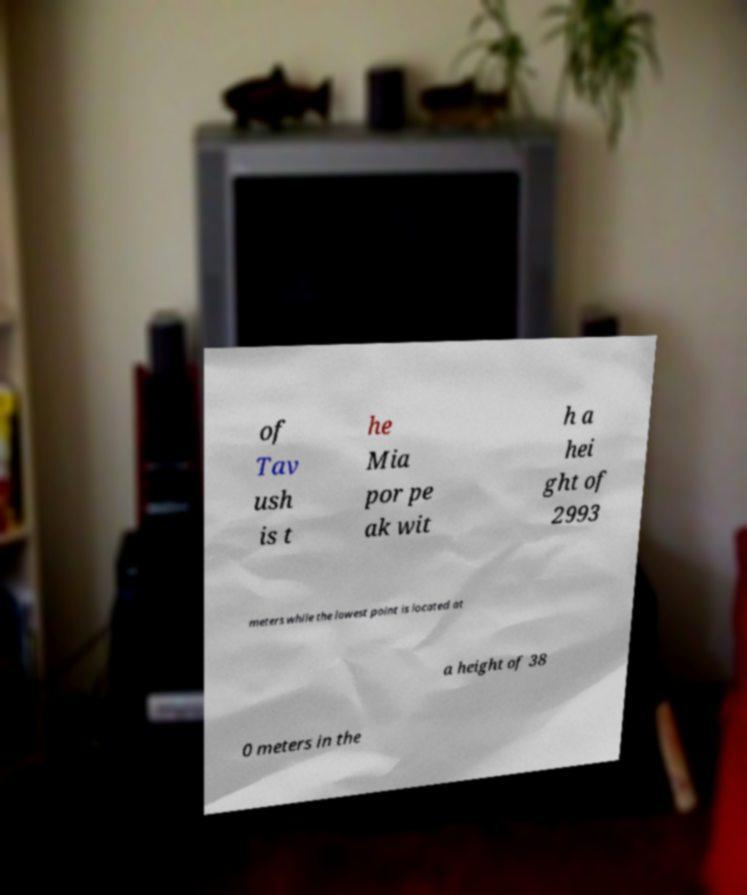Could you extract and type out the text from this image? of Tav ush is t he Mia por pe ak wit h a hei ght of 2993 meters while the lowest point is located at a height of 38 0 meters in the 